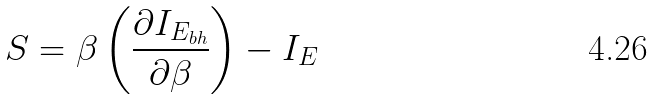<formula> <loc_0><loc_0><loc_500><loc_500>S = \beta \left ( \frac { \partial I _ { E _ { b h } } } { \partial \beta } \right ) - I _ { E }</formula> 